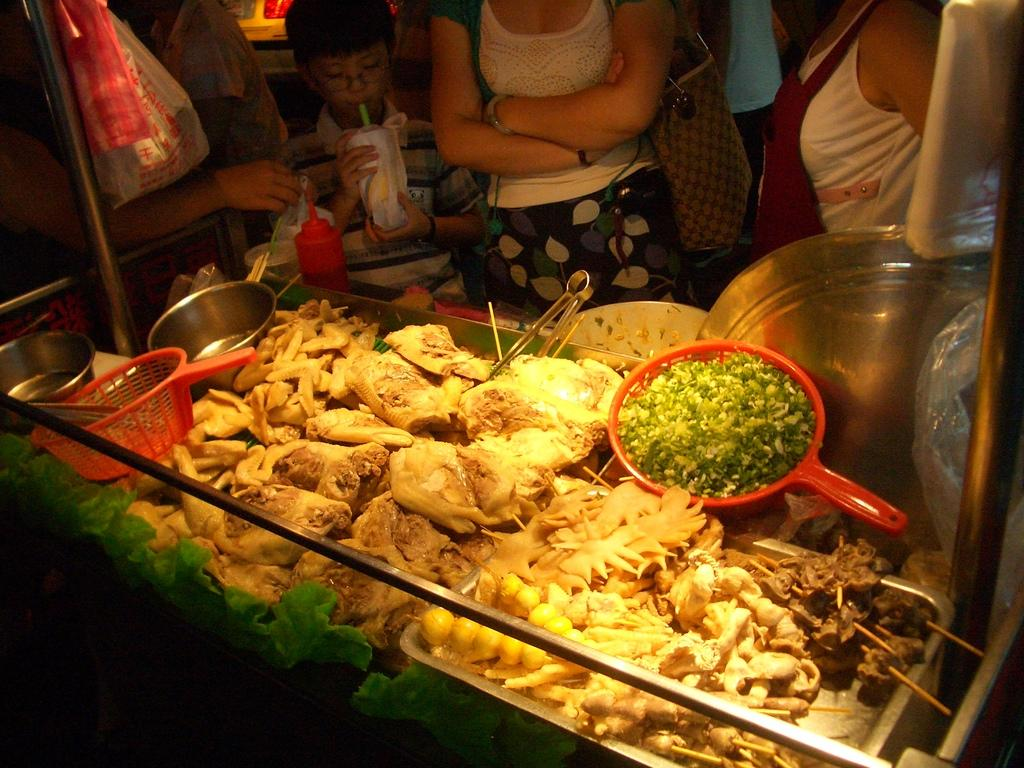What can be found in the trays in the image? There are food items in the trays. What type of containers are present in the image? There are bowls in the image. What other objects can be seen in the image besides the trays and bowls? There are other objects in the image. Are there any people present in the image? Yes, there are people in the image. What direction is the sun facing in the image? There is no sun present in the image. What object is used to eat the food in the image? The provided facts do not mention any forks in the image. 